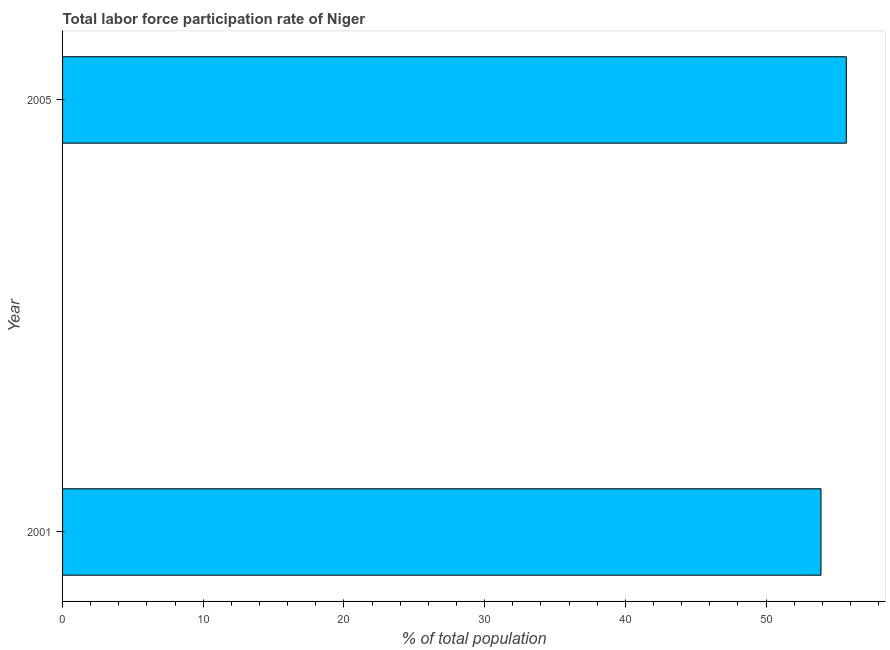Does the graph contain grids?
Your answer should be very brief. No. What is the title of the graph?
Ensure brevity in your answer.  Total labor force participation rate of Niger. What is the label or title of the X-axis?
Make the answer very short. % of total population. What is the label or title of the Y-axis?
Keep it short and to the point. Year. What is the total labor force participation rate in 2001?
Offer a very short reply. 53.9. Across all years, what is the maximum total labor force participation rate?
Offer a very short reply. 55.7. Across all years, what is the minimum total labor force participation rate?
Offer a terse response. 53.9. In which year was the total labor force participation rate maximum?
Ensure brevity in your answer.  2005. What is the sum of the total labor force participation rate?
Your response must be concise. 109.6. What is the average total labor force participation rate per year?
Offer a very short reply. 54.8. What is the median total labor force participation rate?
Offer a terse response. 54.8. What is the ratio of the total labor force participation rate in 2001 to that in 2005?
Provide a succinct answer. 0.97. In how many years, is the total labor force participation rate greater than the average total labor force participation rate taken over all years?
Offer a very short reply. 1. How many years are there in the graph?
Your response must be concise. 2. What is the % of total population of 2001?
Keep it short and to the point. 53.9. What is the % of total population of 2005?
Provide a succinct answer. 55.7. What is the difference between the % of total population in 2001 and 2005?
Provide a short and direct response. -1.8. 